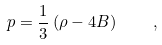Convert formula to latex. <formula><loc_0><loc_0><loc_500><loc_500>p = \frac { 1 } { 3 } \left ( \rho - 4 B \right ) \quad ,</formula> 